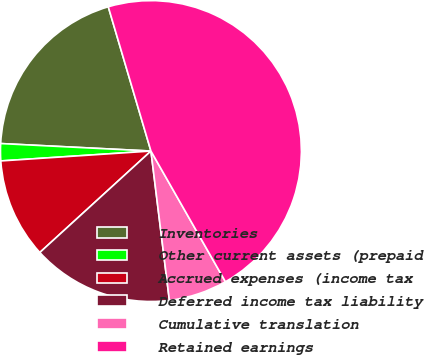Convert chart to OTSL. <chart><loc_0><loc_0><loc_500><loc_500><pie_chart><fcel>Inventories<fcel>Other current assets (prepaid<fcel>Accrued expenses (income tax<fcel>Deferred income tax liability<fcel>Cumulative translation<fcel>Retained earnings<nl><fcel>19.63%<fcel>1.84%<fcel>10.73%<fcel>15.18%<fcel>6.29%<fcel>46.33%<nl></chart> 